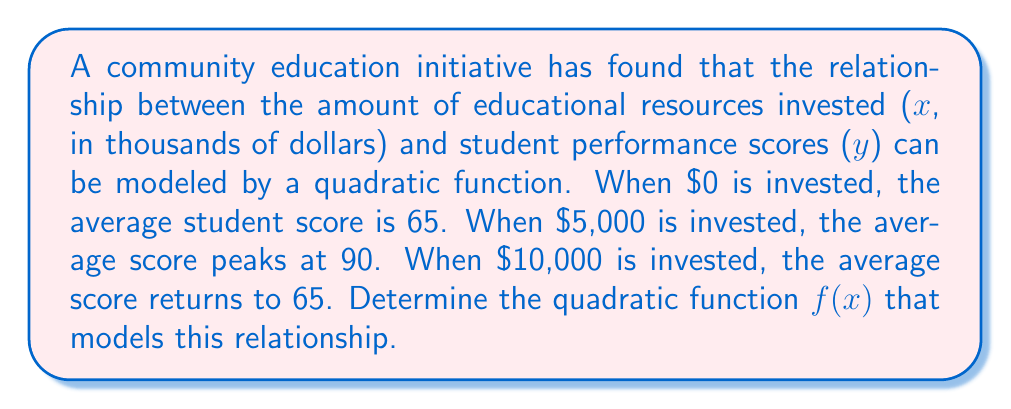Solve this math problem. 1) The general form of a quadratic function is $f(x) = ax^2 + bx + c$

2) We have three points: (0, 65), (5, 90), and (10, 65)

3) Using the vertex form of a quadratic function: $f(x) = a(x-h)^2 + k$
   Where (h,k) is the vertex, which is (5, 90) in this case

4) Substituting the vertex: $f(x) = a(x-5)^2 + 90$

5) Using the point (0, 65):
   $65 = a(0-5)^2 + 90$
   $65 = 25a + 90$
   $-25 = 25a$
   $a = -1$

6) Therefore, the function is: $f(x) = -(x-5)^2 + 90$

7) Expanding this:
   $f(x) = -(x^2 - 10x + 25) + 90$
   $f(x) = -x^2 + 10x - 25 + 90$
   $f(x) = -x^2 + 10x + 65$

8) Verify with the third point (10, 65):
   $f(10) = -(10)^2 + 10(10) + 65 = -100 + 100 + 65 = 65$
Answer: $f(x) = -x^2 + 10x + 65$ 